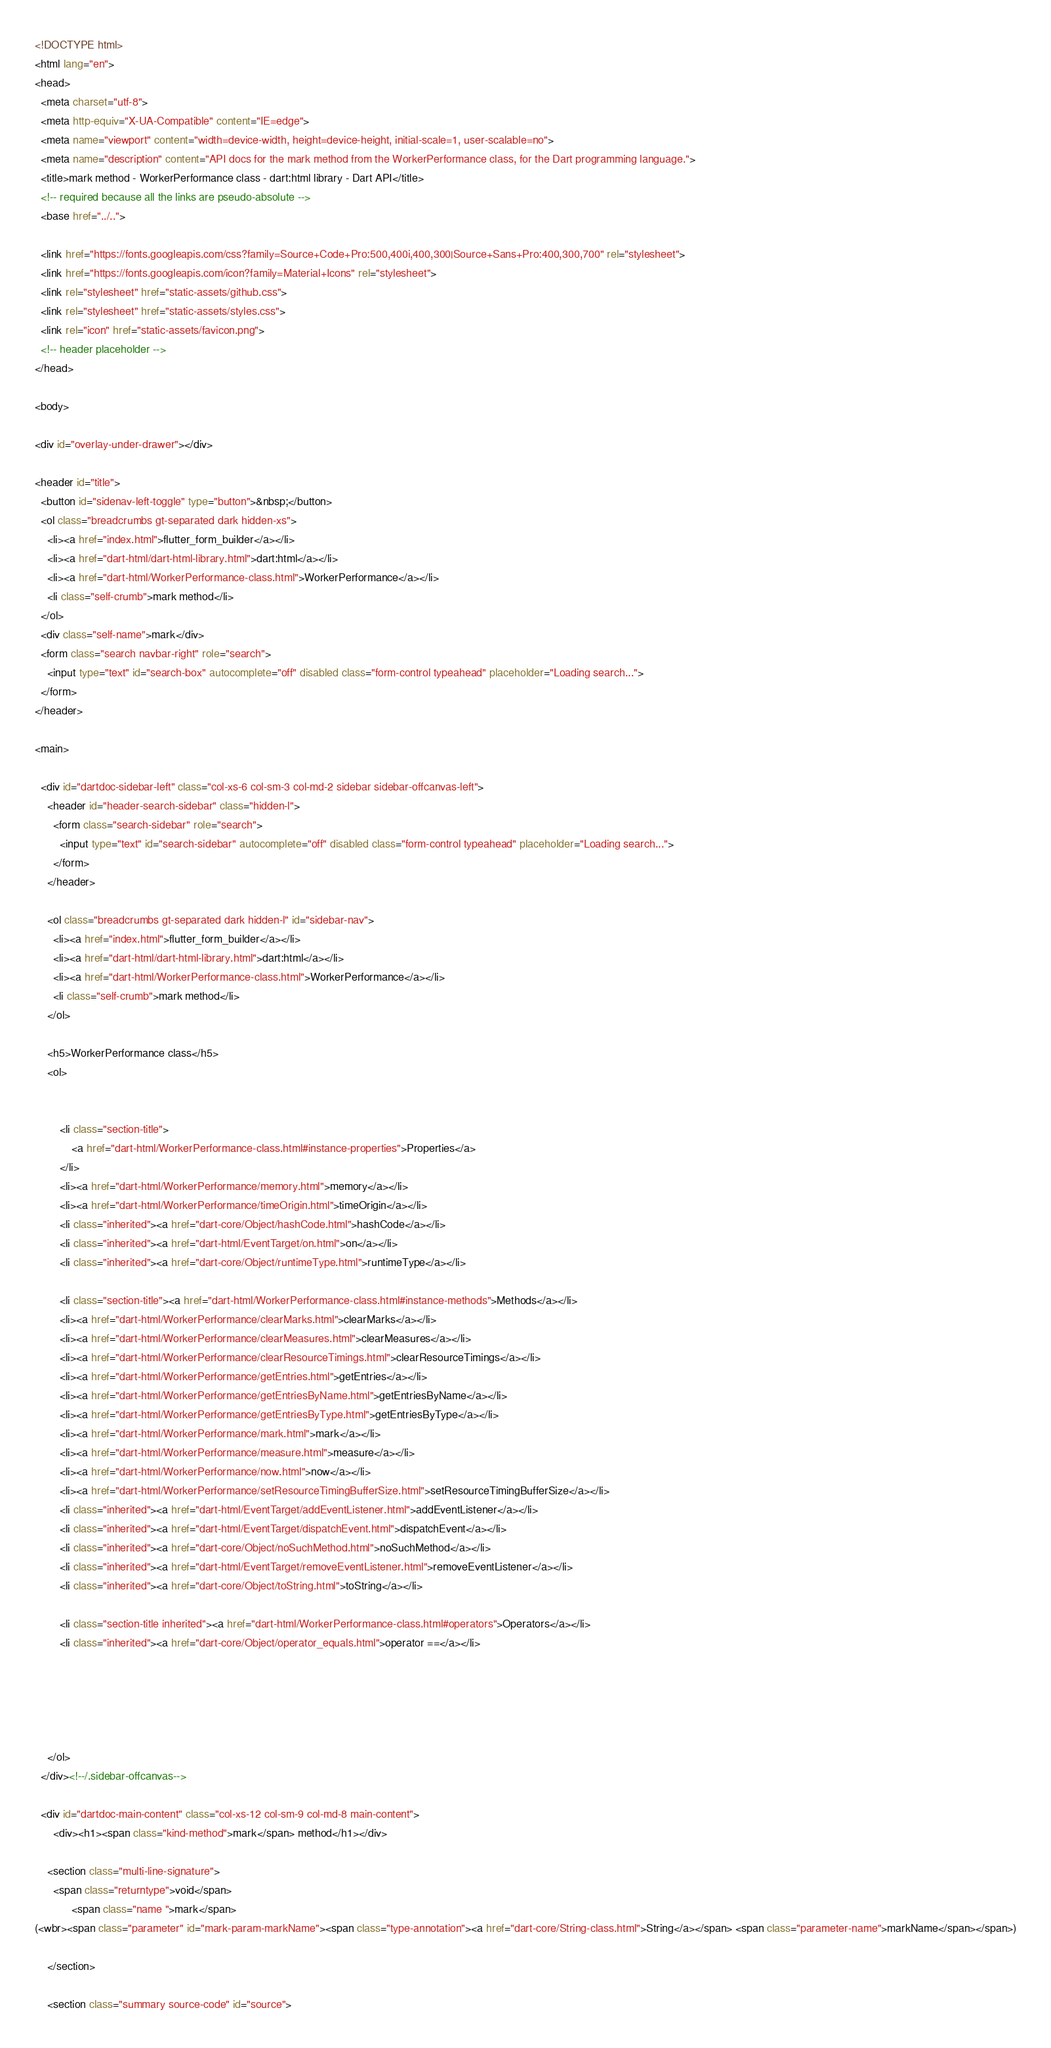<code> <loc_0><loc_0><loc_500><loc_500><_HTML_><!DOCTYPE html>
<html lang="en">
<head>
  <meta charset="utf-8">
  <meta http-equiv="X-UA-Compatible" content="IE=edge">
  <meta name="viewport" content="width=device-width, height=device-height, initial-scale=1, user-scalable=no">
  <meta name="description" content="API docs for the mark method from the WorkerPerformance class, for the Dart programming language.">
  <title>mark method - WorkerPerformance class - dart:html library - Dart API</title>
  <!-- required because all the links are pseudo-absolute -->
  <base href="../..">

  <link href="https://fonts.googleapis.com/css?family=Source+Code+Pro:500,400i,400,300|Source+Sans+Pro:400,300,700" rel="stylesheet">
  <link href="https://fonts.googleapis.com/icon?family=Material+Icons" rel="stylesheet">
  <link rel="stylesheet" href="static-assets/github.css">
  <link rel="stylesheet" href="static-assets/styles.css">
  <link rel="icon" href="static-assets/favicon.png">
  <!-- header placeholder -->
</head>

<body>

<div id="overlay-under-drawer"></div>

<header id="title">
  <button id="sidenav-left-toggle" type="button">&nbsp;</button>
  <ol class="breadcrumbs gt-separated dark hidden-xs">
    <li><a href="index.html">flutter_form_builder</a></li>
    <li><a href="dart-html/dart-html-library.html">dart:html</a></li>
    <li><a href="dart-html/WorkerPerformance-class.html">WorkerPerformance</a></li>
    <li class="self-crumb">mark method</li>
  </ol>
  <div class="self-name">mark</div>
  <form class="search navbar-right" role="search">
    <input type="text" id="search-box" autocomplete="off" disabled class="form-control typeahead" placeholder="Loading search...">
  </form>
</header>

<main>

  <div id="dartdoc-sidebar-left" class="col-xs-6 col-sm-3 col-md-2 sidebar sidebar-offcanvas-left">
    <header id="header-search-sidebar" class="hidden-l">
      <form class="search-sidebar" role="search">
        <input type="text" id="search-sidebar" autocomplete="off" disabled class="form-control typeahead" placeholder="Loading search...">
      </form>
    </header>
    
    <ol class="breadcrumbs gt-separated dark hidden-l" id="sidebar-nav">
      <li><a href="index.html">flutter_form_builder</a></li>
      <li><a href="dart-html/dart-html-library.html">dart:html</a></li>
      <li><a href="dart-html/WorkerPerformance-class.html">WorkerPerformance</a></li>
      <li class="self-crumb">mark method</li>
    </ol>
    
    <h5>WorkerPerformance class</h5>
    <ol>
    
    
        <li class="section-title">
            <a href="dart-html/WorkerPerformance-class.html#instance-properties">Properties</a>
        </li>
        <li><a href="dart-html/WorkerPerformance/memory.html">memory</a></li>
        <li><a href="dart-html/WorkerPerformance/timeOrigin.html">timeOrigin</a></li>
        <li class="inherited"><a href="dart-core/Object/hashCode.html">hashCode</a></li>
        <li class="inherited"><a href="dart-html/EventTarget/on.html">on</a></li>
        <li class="inherited"><a href="dart-core/Object/runtimeType.html">runtimeType</a></li>
    
        <li class="section-title"><a href="dart-html/WorkerPerformance-class.html#instance-methods">Methods</a></li>
        <li><a href="dart-html/WorkerPerformance/clearMarks.html">clearMarks</a></li>
        <li><a href="dart-html/WorkerPerformance/clearMeasures.html">clearMeasures</a></li>
        <li><a href="dart-html/WorkerPerformance/clearResourceTimings.html">clearResourceTimings</a></li>
        <li><a href="dart-html/WorkerPerformance/getEntries.html">getEntries</a></li>
        <li><a href="dart-html/WorkerPerformance/getEntriesByName.html">getEntriesByName</a></li>
        <li><a href="dart-html/WorkerPerformance/getEntriesByType.html">getEntriesByType</a></li>
        <li><a href="dart-html/WorkerPerformance/mark.html">mark</a></li>
        <li><a href="dart-html/WorkerPerformance/measure.html">measure</a></li>
        <li><a href="dart-html/WorkerPerformance/now.html">now</a></li>
        <li><a href="dart-html/WorkerPerformance/setResourceTimingBufferSize.html">setResourceTimingBufferSize</a></li>
        <li class="inherited"><a href="dart-html/EventTarget/addEventListener.html">addEventListener</a></li>
        <li class="inherited"><a href="dart-html/EventTarget/dispatchEvent.html">dispatchEvent</a></li>
        <li class="inherited"><a href="dart-core/Object/noSuchMethod.html">noSuchMethod</a></li>
        <li class="inherited"><a href="dart-html/EventTarget/removeEventListener.html">removeEventListener</a></li>
        <li class="inherited"><a href="dart-core/Object/toString.html">toString</a></li>
    
        <li class="section-title inherited"><a href="dart-html/WorkerPerformance-class.html#operators">Operators</a></li>
        <li class="inherited"><a href="dart-core/Object/operator_equals.html">operator ==</a></li>
    
    
    
    
    
    </ol>
  </div><!--/.sidebar-offcanvas-->

  <div id="dartdoc-main-content" class="col-xs-12 col-sm-9 col-md-8 main-content">
      <div><h1><span class="kind-method">mark</span> method</h1></div>

    <section class="multi-line-signature">
      <span class="returntype">void</span>
            <span class="name ">mark</span>
(<wbr><span class="parameter" id="mark-param-markName"><span class="type-annotation"><a href="dart-core/String-class.html">String</a></span> <span class="parameter-name">markName</span></span>)
      
    </section>
    
    <section class="summary source-code" id="source"></code> 